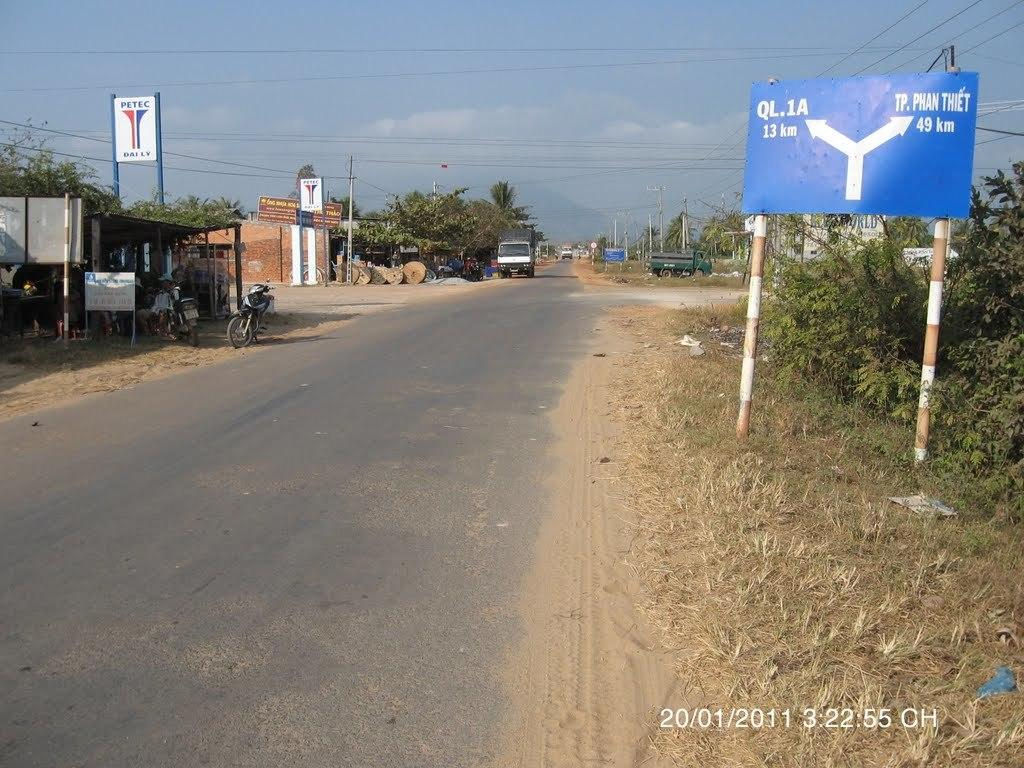<image>
Present a compact description of the photo's key features. A blue sign on the right of the road showing that QL.1A is 13km away. 